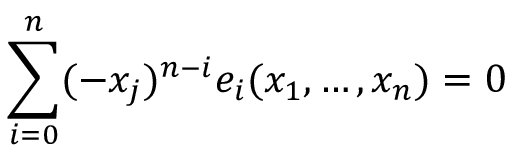<formula> <loc_0><loc_0><loc_500><loc_500>\sum _ { i = 0 } ^ { n } ( - x _ { j } ) ^ { n - i } e _ { i } ( x _ { 1 } , \dots c , x _ { n } ) = 0</formula> 